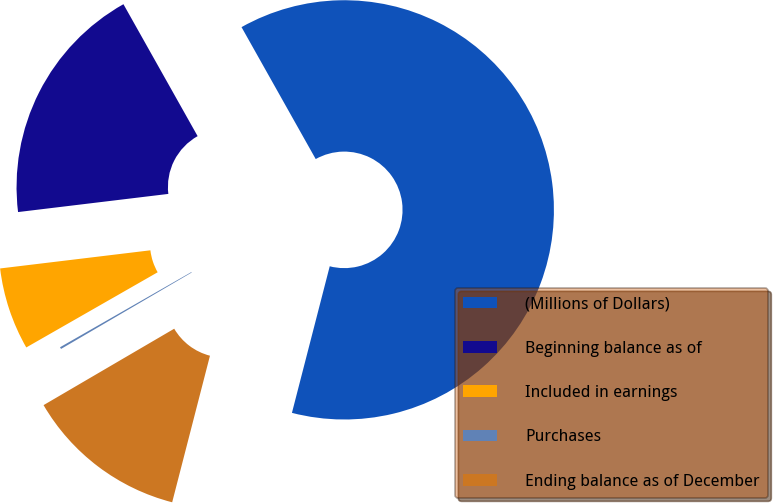Convert chart to OTSL. <chart><loc_0><loc_0><loc_500><loc_500><pie_chart><fcel>(Millions of Dollars)<fcel>Beginning balance as of<fcel>Included in earnings<fcel>Purchases<fcel>Ending balance as of December<nl><fcel>62.17%<fcel>18.76%<fcel>6.36%<fcel>0.15%<fcel>12.56%<nl></chart> 